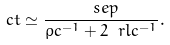<formula> <loc_0><loc_0><loc_500><loc_500>c t \simeq \frac { \ s e p } { \rho c ^ { - 1 } + 2 \ r l c ^ { - 1 } } .</formula> 